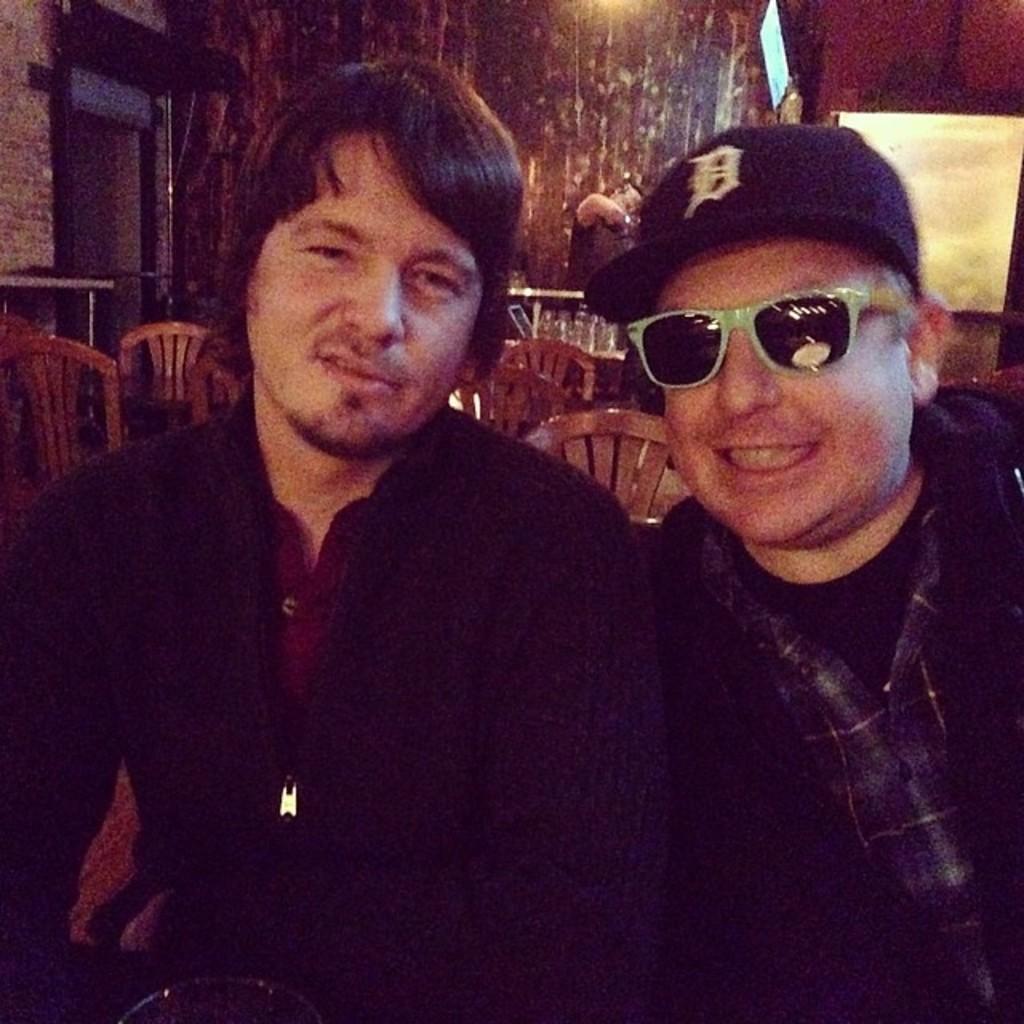Could you give a brief overview of what you see in this image? In this picture I can see two persons, one person is wearing cap and spectacles. 